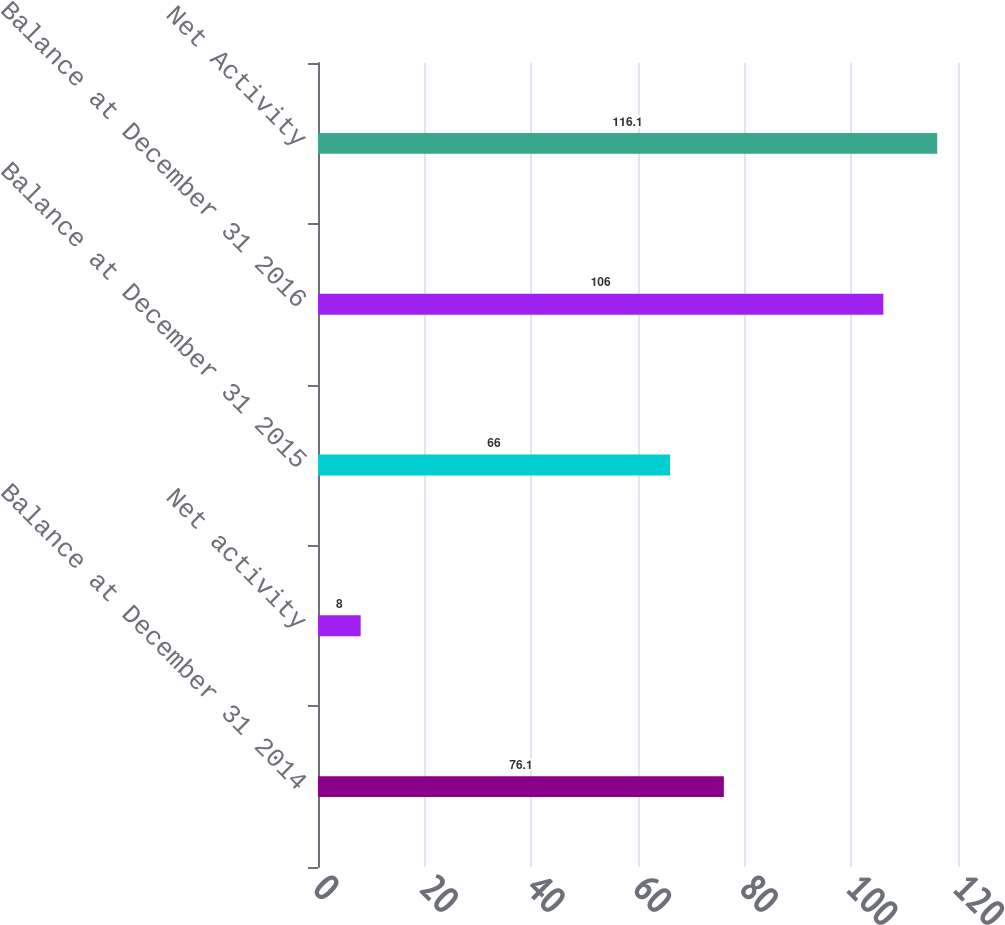<chart> <loc_0><loc_0><loc_500><loc_500><bar_chart><fcel>Balance at December 31 2014<fcel>Net activity<fcel>Balance at December 31 2015<fcel>Balance at December 31 2016<fcel>Net Activity<nl><fcel>76.1<fcel>8<fcel>66<fcel>106<fcel>116.1<nl></chart> 